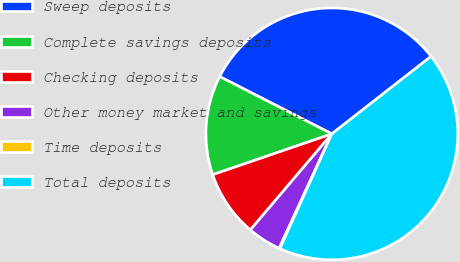Convert chart to OTSL. <chart><loc_0><loc_0><loc_500><loc_500><pie_chart><fcel>Sweep deposits<fcel>Complete savings deposits<fcel>Checking deposits<fcel>Other money market and savings<fcel>Time deposits<fcel>Total deposits<nl><fcel>31.93%<fcel>12.77%<fcel>8.55%<fcel>4.33%<fcel>0.1%<fcel>42.32%<nl></chart> 